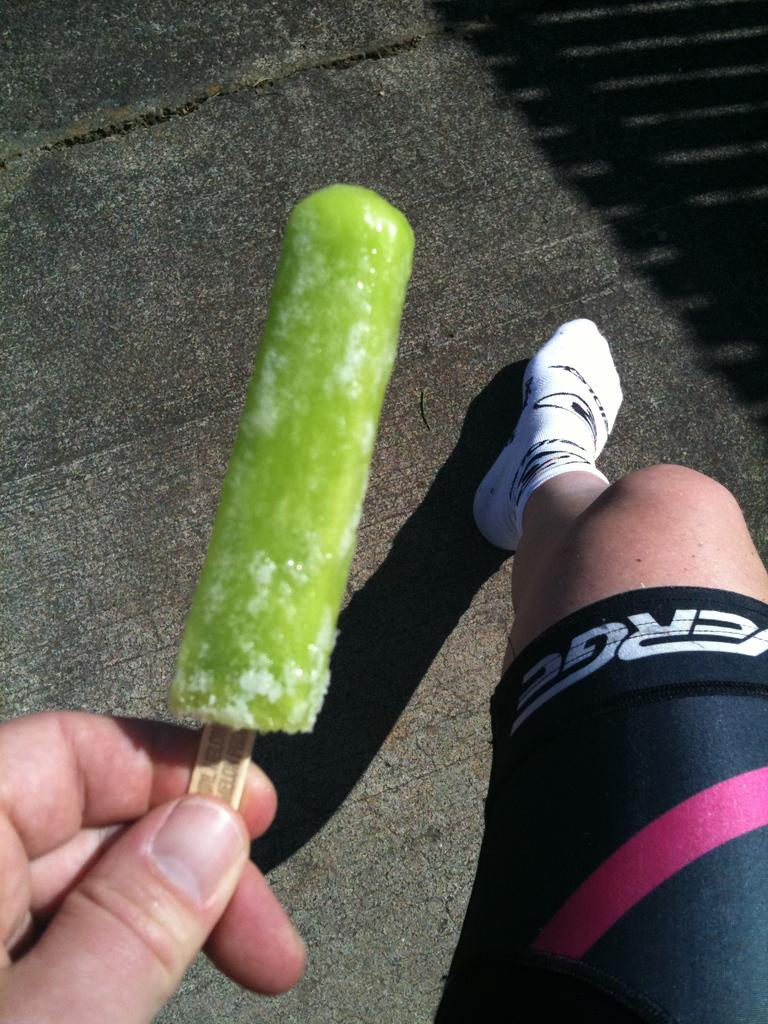Who is present in the image? There is a man in the image. What is the man holding in the image? The man is holding an ice-cream. What is visible at the bottom of the image? There is a road at the bottom of the image. What type of clothing is the man wearing on his feet? The man is wearing white socks. What type of credit card is the beggar using to buy the ice-cream in the image? There is no beggar present in the image, nor is there any mention of a credit card or transaction. 